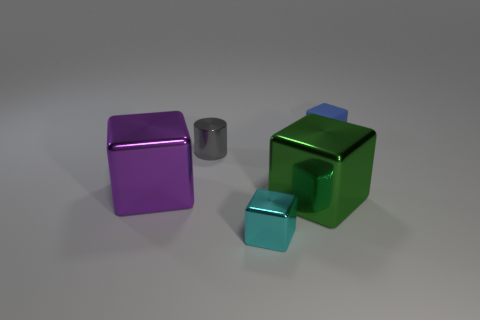Is there a blue block made of the same material as the green object?
Ensure brevity in your answer.  No. There is a tiny block on the left side of the tiny blue object; are there any large shiny things on the left side of it?
Your answer should be very brief. Yes. There is a tiny thing that is in front of the large green metallic block; what is it made of?
Provide a short and direct response. Metal. Does the gray shiny thing have the same shape as the small blue thing?
Offer a terse response. No. There is a small object that is on the left side of the tiny shiny thing that is in front of the small shiny object that is behind the small metal block; what is its color?
Your response must be concise. Gray. What number of cyan things have the same shape as the big purple shiny thing?
Ensure brevity in your answer.  1. How big is the block that is left of the cyan object in front of the large purple cube?
Offer a very short reply. Large. Do the cylinder and the blue thing have the same size?
Ensure brevity in your answer.  Yes. Are there any tiny matte blocks in front of the tiny shiny thing that is left of the small block that is left of the small blue rubber thing?
Offer a very short reply. No. The purple metallic cube has what size?
Provide a succinct answer. Large. 